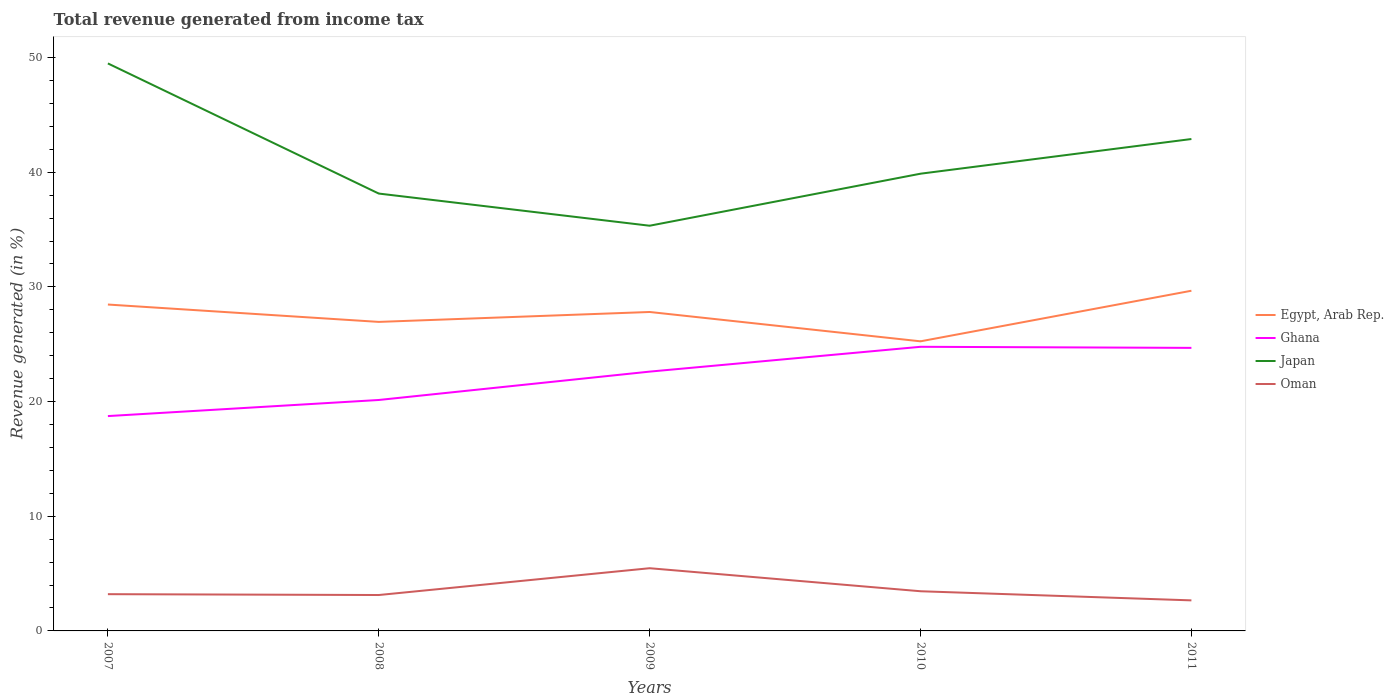How many different coloured lines are there?
Keep it short and to the point. 4. Across all years, what is the maximum total revenue generated in Ghana?
Offer a very short reply. 18.74. What is the total total revenue generated in Japan in the graph?
Your response must be concise. 11.35. What is the difference between the highest and the second highest total revenue generated in Oman?
Give a very brief answer. 2.8. Is the total revenue generated in Egypt, Arab Rep. strictly greater than the total revenue generated in Ghana over the years?
Make the answer very short. No. How many years are there in the graph?
Give a very brief answer. 5. What is the difference between two consecutive major ticks on the Y-axis?
Offer a terse response. 10. Are the values on the major ticks of Y-axis written in scientific E-notation?
Give a very brief answer. No. Does the graph contain any zero values?
Keep it short and to the point. No. Does the graph contain grids?
Offer a terse response. No. Where does the legend appear in the graph?
Keep it short and to the point. Center right. How are the legend labels stacked?
Make the answer very short. Vertical. What is the title of the graph?
Make the answer very short. Total revenue generated from income tax. Does "High income: nonOECD" appear as one of the legend labels in the graph?
Offer a terse response. No. What is the label or title of the X-axis?
Your response must be concise. Years. What is the label or title of the Y-axis?
Offer a very short reply. Revenue generated (in %). What is the Revenue generated (in %) of Egypt, Arab Rep. in 2007?
Your response must be concise. 28.46. What is the Revenue generated (in %) in Ghana in 2007?
Keep it short and to the point. 18.74. What is the Revenue generated (in %) in Japan in 2007?
Your answer should be very brief. 49.49. What is the Revenue generated (in %) of Oman in 2007?
Your answer should be compact. 3.2. What is the Revenue generated (in %) in Egypt, Arab Rep. in 2008?
Your answer should be compact. 26.95. What is the Revenue generated (in %) of Ghana in 2008?
Provide a short and direct response. 20.14. What is the Revenue generated (in %) of Japan in 2008?
Offer a terse response. 38.14. What is the Revenue generated (in %) in Oman in 2008?
Provide a succinct answer. 3.13. What is the Revenue generated (in %) in Egypt, Arab Rep. in 2009?
Keep it short and to the point. 27.81. What is the Revenue generated (in %) of Ghana in 2009?
Ensure brevity in your answer.  22.61. What is the Revenue generated (in %) of Japan in 2009?
Offer a terse response. 35.34. What is the Revenue generated (in %) of Oman in 2009?
Ensure brevity in your answer.  5.47. What is the Revenue generated (in %) in Egypt, Arab Rep. in 2010?
Your response must be concise. 25.26. What is the Revenue generated (in %) of Ghana in 2010?
Provide a succinct answer. 24.78. What is the Revenue generated (in %) in Japan in 2010?
Make the answer very short. 39.87. What is the Revenue generated (in %) in Oman in 2010?
Keep it short and to the point. 3.46. What is the Revenue generated (in %) of Egypt, Arab Rep. in 2011?
Give a very brief answer. 29.67. What is the Revenue generated (in %) in Ghana in 2011?
Offer a very short reply. 24.68. What is the Revenue generated (in %) of Japan in 2011?
Keep it short and to the point. 42.9. What is the Revenue generated (in %) in Oman in 2011?
Your answer should be very brief. 2.66. Across all years, what is the maximum Revenue generated (in %) in Egypt, Arab Rep.?
Your answer should be compact. 29.67. Across all years, what is the maximum Revenue generated (in %) in Ghana?
Your answer should be compact. 24.78. Across all years, what is the maximum Revenue generated (in %) in Japan?
Offer a terse response. 49.49. Across all years, what is the maximum Revenue generated (in %) of Oman?
Keep it short and to the point. 5.47. Across all years, what is the minimum Revenue generated (in %) in Egypt, Arab Rep.?
Provide a succinct answer. 25.26. Across all years, what is the minimum Revenue generated (in %) in Ghana?
Offer a very short reply. 18.74. Across all years, what is the minimum Revenue generated (in %) of Japan?
Make the answer very short. 35.34. Across all years, what is the minimum Revenue generated (in %) of Oman?
Offer a terse response. 2.66. What is the total Revenue generated (in %) of Egypt, Arab Rep. in the graph?
Your response must be concise. 138.15. What is the total Revenue generated (in %) of Ghana in the graph?
Offer a terse response. 110.95. What is the total Revenue generated (in %) of Japan in the graph?
Your answer should be compact. 205.73. What is the total Revenue generated (in %) in Oman in the graph?
Keep it short and to the point. 17.93. What is the difference between the Revenue generated (in %) in Egypt, Arab Rep. in 2007 and that in 2008?
Give a very brief answer. 1.51. What is the difference between the Revenue generated (in %) in Ghana in 2007 and that in 2008?
Your response must be concise. -1.4. What is the difference between the Revenue generated (in %) in Japan in 2007 and that in 2008?
Keep it short and to the point. 11.35. What is the difference between the Revenue generated (in %) of Oman in 2007 and that in 2008?
Provide a short and direct response. 0.07. What is the difference between the Revenue generated (in %) in Egypt, Arab Rep. in 2007 and that in 2009?
Your response must be concise. 0.65. What is the difference between the Revenue generated (in %) in Ghana in 2007 and that in 2009?
Ensure brevity in your answer.  -3.88. What is the difference between the Revenue generated (in %) of Japan in 2007 and that in 2009?
Offer a terse response. 14.15. What is the difference between the Revenue generated (in %) in Oman in 2007 and that in 2009?
Offer a very short reply. -2.26. What is the difference between the Revenue generated (in %) in Egypt, Arab Rep. in 2007 and that in 2010?
Provide a succinct answer. 3.21. What is the difference between the Revenue generated (in %) in Ghana in 2007 and that in 2010?
Your answer should be compact. -6.04. What is the difference between the Revenue generated (in %) in Japan in 2007 and that in 2010?
Keep it short and to the point. 9.62. What is the difference between the Revenue generated (in %) of Oman in 2007 and that in 2010?
Make the answer very short. -0.26. What is the difference between the Revenue generated (in %) in Egypt, Arab Rep. in 2007 and that in 2011?
Ensure brevity in your answer.  -1.2. What is the difference between the Revenue generated (in %) in Ghana in 2007 and that in 2011?
Your answer should be very brief. -5.95. What is the difference between the Revenue generated (in %) of Japan in 2007 and that in 2011?
Provide a short and direct response. 6.59. What is the difference between the Revenue generated (in %) of Oman in 2007 and that in 2011?
Give a very brief answer. 0.54. What is the difference between the Revenue generated (in %) of Egypt, Arab Rep. in 2008 and that in 2009?
Your response must be concise. -0.86. What is the difference between the Revenue generated (in %) of Ghana in 2008 and that in 2009?
Your answer should be very brief. -2.47. What is the difference between the Revenue generated (in %) of Japan in 2008 and that in 2009?
Ensure brevity in your answer.  2.8. What is the difference between the Revenue generated (in %) in Oman in 2008 and that in 2009?
Your answer should be compact. -2.34. What is the difference between the Revenue generated (in %) in Egypt, Arab Rep. in 2008 and that in 2010?
Keep it short and to the point. 1.69. What is the difference between the Revenue generated (in %) in Ghana in 2008 and that in 2010?
Your response must be concise. -4.64. What is the difference between the Revenue generated (in %) of Japan in 2008 and that in 2010?
Your answer should be very brief. -1.73. What is the difference between the Revenue generated (in %) in Oman in 2008 and that in 2010?
Ensure brevity in your answer.  -0.33. What is the difference between the Revenue generated (in %) of Egypt, Arab Rep. in 2008 and that in 2011?
Ensure brevity in your answer.  -2.72. What is the difference between the Revenue generated (in %) in Ghana in 2008 and that in 2011?
Offer a terse response. -4.54. What is the difference between the Revenue generated (in %) of Japan in 2008 and that in 2011?
Give a very brief answer. -4.76. What is the difference between the Revenue generated (in %) of Oman in 2008 and that in 2011?
Offer a very short reply. 0.47. What is the difference between the Revenue generated (in %) of Egypt, Arab Rep. in 2009 and that in 2010?
Keep it short and to the point. 2.56. What is the difference between the Revenue generated (in %) in Ghana in 2009 and that in 2010?
Your answer should be very brief. -2.16. What is the difference between the Revenue generated (in %) in Japan in 2009 and that in 2010?
Provide a short and direct response. -4.54. What is the difference between the Revenue generated (in %) in Oman in 2009 and that in 2010?
Give a very brief answer. 2.01. What is the difference between the Revenue generated (in %) of Egypt, Arab Rep. in 2009 and that in 2011?
Keep it short and to the point. -1.85. What is the difference between the Revenue generated (in %) of Ghana in 2009 and that in 2011?
Offer a very short reply. -2.07. What is the difference between the Revenue generated (in %) of Japan in 2009 and that in 2011?
Provide a succinct answer. -7.56. What is the difference between the Revenue generated (in %) of Oman in 2009 and that in 2011?
Your answer should be very brief. 2.8. What is the difference between the Revenue generated (in %) in Egypt, Arab Rep. in 2010 and that in 2011?
Provide a short and direct response. -4.41. What is the difference between the Revenue generated (in %) in Ghana in 2010 and that in 2011?
Give a very brief answer. 0.09. What is the difference between the Revenue generated (in %) of Japan in 2010 and that in 2011?
Provide a succinct answer. -3.02. What is the difference between the Revenue generated (in %) in Oman in 2010 and that in 2011?
Keep it short and to the point. 0.8. What is the difference between the Revenue generated (in %) in Egypt, Arab Rep. in 2007 and the Revenue generated (in %) in Ghana in 2008?
Keep it short and to the point. 8.32. What is the difference between the Revenue generated (in %) of Egypt, Arab Rep. in 2007 and the Revenue generated (in %) of Japan in 2008?
Offer a very short reply. -9.68. What is the difference between the Revenue generated (in %) in Egypt, Arab Rep. in 2007 and the Revenue generated (in %) in Oman in 2008?
Offer a very short reply. 25.33. What is the difference between the Revenue generated (in %) in Ghana in 2007 and the Revenue generated (in %) in Japan in 2008?
Offer a very short reply. -19.41. What is the difference between the Revenue generated (in %) of Ghana in 2007 and the Revenue generated (in %) of Oman in 2008?
Your answer should be very brief. 15.6. What is the difference between the Revenue generated (in %) of Japan in 2007 and the Revenue generated (in %) of Oman in 2008?
Your answer should be very brief. 46.36. What is the difference between the Revenue generated (in %) in Egypt, Arab Rep. in 2007 and the Revenue generated (in %) in Ghana in 2009?
Give a very brief answer. 5.85. What is the difference between the Revenue generated (in %) in Egypt, Arab Rep. in 2007 and the Revenue generated (in %) in Japan in 2009?
Offer a terse response. -6.87. What is the difference between the Revenue generated (in %) in Egypt, Arab Rep. in 2007 and the Revenue generated (in %) in Oman in 2009?
Offer a very short reply. 22.99. What is the difference between the Revenue generated (in %) in Ghana in 2007 and the Revenue generated (in %) in Japan in 2009?
Keep it short and to the point. -16.6. What is the difference between the Revenue generated (in %) in Ghana in 2007 and the Revenue generated (in %) in Oman in 2009?
Ensure brevity in your answer.  13.27. What is the difference between the Revenue generated (in %) of Japan in 2007 and the Revenue generated (in %) of Oman in 2009?
Give a very brief answer. 44.02. What is the difference between the Revenue generated (in %) of Egypt, Arab Rep. in 2007 and the Revenue generated (in %) of Ghana in 2010?
Provide a short and direct response. 3.69. What is the difference between the Revenue generated (in %) in Egypt, Arab Rep. in 2007 and the Revenue generated (in %) in Japan in 2010?
Provide a short and direct response. -11.41. What is the difference between the Revenue generated (in %) in Egypt, Arab Rep. in 2007 and the Revenue generated (in %) in Oman in 2010?
Offer a very short reply. 25. What is the difference between the Revenue generated (in %) in Ghana in 2007 and the Revenue generated (in %) in Japan in 2010?
Provide a succinct answer. -21.14. What is the difference between the Revenue generated (in %) of Ghana in 2007 and the Revenue generated (in %) of Oman in 2010?
Your answer should be compact. 15.28. What is the difference between the Revenue generated (in %) in Japan in 2007 and the Revenue generated (in %) in Oman in 2010?
Your answer should be very brief. 46.03. What is the difference between the Revenue generated (in %) in Egypt, Arab Rep. in 2007 and the Revenue generated (in %) in Ghana in 2011?
Offer a terse response. 3.78. What is the difference between the Revenue generated (in %) of Egypt, Arab Rep. in 2007 and the Revenue generated (in %) of Japan in 2011?
Your answer should be compact. -14.43. What is the difference between the Revenue generated (in %) in Egypt, Arab Rep. in 2007 and the Revenue generated (in %) in Oman in 2011?
Make the answer very short. 25.8. What is the difference between the Revenue generated (in %) of Ghana in 2007 and the Revenue generated (in %) of Japan in 2011?
Your answer should be very brief. -24.16. What is the difference between the Revenue generated (in %) of Ghana in 2007 and the Revenue generated (in %) of Oman in 2011?
Provide a short and direct response. 16.07. What is the difference between the Revenue generated (in %) of Japan in 2007 and the Revenue generated (in %) of Oman in 2011?
Your response must be concise. 46.83. What is the difference between the Revenue generated (in %) in Egypt, Arab Rep. in 2008 and the Revenue generated (in %) in Ghana in 2009?
Make the answer very short. 4.34. What is the difference between the Revenue generated (in %) in Egypt, Arab Rep. in 2008 and the Revenue generated (in %) in Japan in 2009?
Your answer should be very brief. -8.39. What is the difference between the Revenue generated (in %) in Egypt, Arab Rep. in 2008 and the Revenue generated (in %) in Oman in 2009?
Keep it short and to the point. 21.48. What is the difference between the Revenue generated (in %) in Ghana in 2008 and the Revenue generated (in %) in Japan in 2009?
Offer a terse response. -15.2. What is the difference between the Revenue generated (in %) of Ghana in 2008 and the Revenue generated (in %) of Oman in 2009?
Your response must be concise. 14.67. What is the difference between the Revenue generated (in %) of Japan in 2008 and the Revenue generated (in %) of Oman in 2009?
Keep it short and to the point. 32.67. What is the difference between the Revenue generated (in %) of Egypt, Arab Rep. in 2008 and the Revenue generated (in %) of Ghana in 2010?
Provide a succinct answer. 2.17. What is the difference between the Revenue generated (in %) in Egypt, Arab Rep. in 2008 and the Revenue generated (in %) in Japan in 2010?
Provide a succinct answer. -12.92. What is the difference between the Revenue generated (in %) in Egypt, Arab Rep. in 2008 and the Revenue generated (in %) in Oman in 2010?
Offer a very short reply. 23.49. What is the difference between the Revenue generated (in %) in Ghana in 2008 and the Revenue generated (in %) in Japan in 2010?
Offer a very short reply. -19.73. What is the difference between the Revenue generated (in %) of Ghana in 2008 and the Revenue generated (in %) of Oman in 2010?
Offer a very short reply. 16.68. What is the difference between the Revenue generated (in %) of Japan in 2008 and the Revenue generated (in %) of Oman in 2010?
Provide a succinct answer. 34.68. What is the difference between the Revenue generated (in %) of Egypt, Arab Rep. in 2008 and the Revenue generated (in %) of Ghana in 2011?
Your response must be concise. 2.27. What is the difference between the Revenue generated (in %) in Egypt, Arab Rep. in 2008 and the Revenue generated (in %) in Japan in 2011?
Offer a terse response. -15.95. What is the difference between the Revenue generated (in %) of Egypt, Arab Rep. in 2008 and the Revenue generated (in %) of Oman in 2011?
Your answer should be compact. 24.28. What is the difference between the Revenue generated (in %) in Ghana in 2008 and the Revenue generated (in %) in Japan in 2011?
Ensure brevity in your answer.  -22.76. What is the difference between the Revenue generated (in %) of Ghana in 2008 and the Revenue generated (in %) of Oman in 2011?
Keep it short and to the point. 17.48. What is the difference between the Revenue generated (in %) of Japan in 2008 and the Revenue generated (in %) of Oman in 2011?
Give a very brief answer. 35.48. What is the difference between the Revenue generated (in %) in Egypt, Arab Rep. in 2009 and the Revenue generated (in %) in Ghana in 2010?
Keep it short and to the point. 3.04. What is the difference between the Revenue generated (in %) of Egypt, Arab Rep. in 2009 and the Revenue generated (in %) of Japan in 2010?
Provide a short and direct response. -12.06. What is the difference between the Revenue generated (in %) in Egypt, Arab Rep. in 2009 and the Revenue generated (in %) in Oman in 2010?
Provide a short and direct response. 24.35. What is the difference between the Revenue generated (in %) in Ghana in 2009 and the Revenue generated (in %) in Japan in 2010?
Provide a succinct answer. -17.26. What is the difference between the Revenue generated (in %) in Ghana in 2009 and the Revenue generated (in %) in Oman in 2010?
Ensure brevity in your answer.  19.15. What is the difference between the Revenue generated (in %) of Japan in 2009 and the Revenue generated (in %) of Oman in 2010?
Give a very brief answer. 31.88. What is the difference between the Revenue generated (in %) of Egypt, Arab Rep. in 2009 and the Revenue generated (in %) of Ghana in 2011?
Keep it short and to the point. 3.13. What is the difference between the Revenue generated (in %) in Egypt, Arab Rep. in 2009 and the Revenue generated (in %) in Japan in 2011?
Provide a succinct answer. -15.08. What is the difference between the Revenue generated (in %) of Egypt, Arab Rep. in 2009 and the Revenue generated (in %) of Oman in 2011?
Provide a succinct answer. 25.15. What is the difference between the Revenue generated (in %) of Ghana in 2009 and the Revenue generated (in %) of Japan in 2011?
Your answer should be compact. -20.28. What is the difference between the Revenue generated (in %) in Ghana in 2009 and the Revenue generated (in %) in Oman in 2011?
Offer a terse response. 19.95. What is the difference between the Revenue generated (in %) in Japan in 2009 and the Revenue generated (in %) in Oman in 2011?
Make the answer very short. 32.67. What is the difference between the Revenue generated (in %) of Egypt, Arab Rep. in 2010 and the Revenue generated (in %) of Ghana in 2011?
Your answer should be very brief. 0.57. What is the difference between the Revenue generated (in %) of Egypt, Arab Rep. in 2010 and the Revenue generated (in %) of Japan in 2011?
Keep it short and to the point. -17.64. What is the difference between the Revenue generated (in %) in Egypt, Arab Rep. in 2010 and the Revenue generated (in %) in Oman in 2011?
Your answer should be very brief. 22.59. What is the difference between the Revenue generated (in %) of Ghana in 2010 and the Revenue generated (in %) of Japan in 2011?
Provide a succinct answer. -18.12. What is the difference between the Revenue generated (in %) in Ghana in 2010 and the Revenue generated (in %) in Oman in 2011?
Offer a very short reply. 22.11. What is the difference between the Revenue generated (in %) in Japan in 2010 and the Revenue generated (in %) in Oman in 2011?
Your answer should be compact. 37.21. What is the average Revenue generated (in %) of Egypt, Arab Rep. per year?
Keep it short and to the point. 27.63. What is the average Revenue generated (in %) in Ghana per year?
Offer a very short reply. 22.19. What is the average Revenue generated (in %) in Japan per year?
Your answer should be compact. 41.15. What is the average Revenue generated (in %) of Oman per year?
Make the answer very short. 3.59. In the year 2007, what is the difference between the Revenue generated (in %) of Egypt, Arab Rep. and Revenue generated (in %) of Ghana?
Your answer should be compact. 9.73. In the year 2007, what is the difference between the Revenue generated (in %) in Egypt, Arab Rep. and Revenue generated (in %) in Japan?
Offer a very short reply. -21.03. In the year 2007, what is the difference between the Revenue generated (in %) in Egypt, Arab Rep. and Revenue generated (in %) in Oman?
Provide a short and direct response. 25.26. In the year 2007, what is the difference between the Revenue generated (in %) in Ghana and Revenue generated (in %) in Japan?
Your answer should be compact. -30.75. In the year 2007, what is the difference between the Revenue generated (in %) of Ghana and Revenue generated (in %) of Oman?
Ensure brevity in your answer.  15.53. In the year 2007, what is the difference between the Revenue generated (in %) in Japan and Revenue generated (in %) in Oman?
Offer a terse response. 46.28. In the year 2008, what is the difference between the Revenue generated (in %) in Egypt, Arab Rep. and Revenue generated (in %) in Ghana?
Your response must be concise. 6.81. In the year 2008, what is the difference between the Revenue generated (in %) in Egypt, Arab Rep. and Revenue generated (in %) in Japan?
Keep it short and to the point. -11.19. In the year 2008, what is the difference between the Revenue generated (in %) of Egypt, Arab Rep. and Revenue generated (in %) of Oman?
Your answer should be very brief. 23.82. In the year 2008, what is the difference between the Revenue generated (in %) in Ghana and Revenue generated (in %) in Japan?
Provide a succinct answer. -18. In the year 2008, what is the difference between the Revenue generated (in %) of Ghana and Revenue generated (in %) of Oman?
Keep it short and to the point. 17.01. In the year 2008, what is the difference between the Revenue generated (in %) of Japan and Revenue generated (in %) of Oman?
Offer a very short reply. 35.01. In the year 2009, what is the difference between the Revenue generated (in %) of Egypt, Arab Rep. and Revenue generated (in %) of Ghana?
Offer a terse response. 5.2. In the year 2009, what is the difference between the Revenue generated (in %) of Egypt, Arab Rep. and Revenue generated (in %) of Japan?
Provide a short and direct response. -7.52. In the year 2009, what is the difference between the Revenue generated (in %) in Egypt, Arab Rep. and Revenue generated (in %) in Oman?
Offer a very short reply. 22.35. In the year 2009, what is the difference between the Revenue generated (in %) in Ghana and Revenue generated (in %) in Japan?
Your response must be concise. -12.72. In the year 2009, what is the difference between the Revenue generated (in %) in Ghana and Revenue generated (in %) in Oman?
Provide a succinct answer. 17.15. In the year 2009, what is the difference between the Revenue generated (in %) of Japan and Revenue generated (in %) of Oman?
Offer a terse response. 29.87. In the year 2010, what is the difference between the Revenue generated (in %) of Egypt, Arab Rep. and Revenue generated (in %) of Ghana?
Offer a very short reply. 0.48. In the year 2010, what is the difference between the Revenue generated (in %) in Egypt, Arab Rep. and Revenue generated (in %) in Japan?
Provide a short and direct response. -14.62. In the year 2010, what is the difference between the Revenue generated (in %) in Egypt, Arab Rep. and Revenue generated (in %) in Oman?
Make the answer very short. 21.8. In the year 2010, what is the difference between the Revenue generated (in %) in Ghana and Revenue generated (in %) in Japan?
Provide a short and direct response. -15.1. In the year 2010, what is the difference between the Revenue generated (in %) of Ghana and Revenue generated (in %) of Oman?
Keep it short and to the point. 21.32. In the year 2010, what is the difference between the Revenue generated (in %) of Japan and Revenue generated (in %) of Oman?
Keep it short and to the point. 36.41. In the year 2011, what is the difference between the Revenue generated (in %) in Egypt, Arab Rep. and Revenue generated (in %) in Ghana?
Offer a very short reply. 4.98. In the year 2011, what is the difference between the Revenue generated (in %) in Egypt, Arab Rep. and Revenue generated (in %) in Japan?
Ensure brevity in your answer.  -13.23. In the year 2011, what is the difference between the Revenue generated (in %) of Egypt, Arab Rep. and Revenue generated (in %) of Oman?
Keep it short and to the point. 27. In the year 2011, what is the difference between the Revenue generated (in %) of Ghana and Revenue generated (in %) of Japan?
Offer a terse response. -18.21. In the year 2011, what is the difference between the Revenue generated (in %) in Ghana and Revenue generated (in %) in Oman?
Make the answer very short. 22.02. In the year 2011, what is the difference between the Revenue generated (in %) of Japan and Revenue generated (in %) of Oman?
Offer a terse response. 40.23. What is the ratio of the Revenue generated (in %) in Egypt, Arab Rep. in 2007 to that in 2008?
Your answer should be very brief. 1.06. What is the ratio of the Revenue generated (in %) of Ghana in 2007 to that in 2008?
Provide a succinct answer. 0.93. What is the ratio of the Revenue generated (in %) of Japan in 2007 to that in 2008?
Offer a terse response. 1.3. What is the ratio of the Revenue generated (in %) of Oman in 2007 to that in 2008?
Provide a short and direct response. 1.02. What is the ratio of the Revenue generated (in %) of Egypt, Arab Rep. in 2007 to that in 2009?
Give a very brief answer. 1.02. What is the ratio of the Revenue generated (in %) of Ghana in 2007 to that in 2009?
Make the answer very short. 0.83. What is the ratio of the Revenue generated (in %) in Japan in 2007 to that in 2009?
Your answer should be compact. 1.4. What is the ratio of the Revenue generated (in %) in Oman in 2007 to that in 2009?
Your response must be concise. 0.59. What is the ratio of the Revenue generated (in %) in Egypt, Arab Rep. in 2007 to that in 2010?
Provide a short and direct response. 1.13. What is the ratio of the Revenue generated (in %) in Ghana in 2007 to that in 2010?
Provide a short and direct response. 0.76. What is the ratio of the Revenue generated (in %) of Japan in 2007 to that in 2010?
Give a very brief answer. 1.24. What is the ratio of the Revenue generated (in %) in Oman in 2007 to that in 2010?
Give a very brief answer. 0.93. What is the ratio of the Revenue generated (in %) in Egypt, Arab Rep. in 2007 to that in 2011?
Provide a succinct answer. 0.96. What is the ratio of the Revenue generated (in %) in Ghana in 2007 to that in 2011?
Your answer should be compact. 0.76. What is the ratio of the Revenue generated (in %) of Japan in 2007 to that in 2011?
Ensure brevity in your answer.  1.15. What is the ratio of the Revenue generated (in %) of Oman in 2007 to that in 2011?
Keep it short and to the point. 1.2. What is the ratio of the Revenue generated (in %) in Egypt, Arab Rep. in 2008 to that in 2009?
Your response must be concise. 0.97. What is the ratio of the Revenue generated (in %) in Ghana in 2008 to that in 2009?
Your answer should be very brief. 0.89. What is the ratio of the Revenue generated (in %) in Japan in 2008 to that in 2009?
Offer a very short reply. 1.08. What is the ratio of the Revenue generated (in %) in Oman in 2008 to that in 2009?
Keep it short and to the point. 0.57. What is the ratio of the Revenue generated (in %) in Egypt, Arab Rep. in 2008 to that in 2010?
Your answer should be compact. 1.07. What is the ratio of the Revenue generated (in %) of Ghana in 2008 to that in 2010?
Give a very brief answer. 0.81. What is the ratio of the Revenue generated (in %) in Japan in 2008 to that in 2010?
Offer a terse response. 0.96. What is the ratio of the Revenue generated (in %) in Oman in 2008 to that in 2010?
Keep it short and to the point. 0.9. What is the ratio of the Revenue generated (in %) in Egypt, Arab Rep. in 2008 to that in 2011?
Ensure brevity in your answer.  0.91. What is the ratio of the Revenue generated (in %) in Ghana in 2008 to that in 2011?
Offer a terse response. 0.82. What is the ratio of the Revenue generated (in %) of Japan in 2008 to that in 2011?
Keep it short and to the point. 0.89. What is the ratio of the Revenue generated (in %) in Oman in 2008 to that in 2011?
Provide a succinct answer. 1.18. What is the ratio of the Revenue generated (in %) in Egypt, Arab Rep. in 2009 to that in 2010?
Offer a terse response. 1.1. What is the ratio of the Revenue generated (in %) of Ghana in 2009 to that in 2010?
Your response must be concise. 0.91. What is the ratio of the Revenue generated (in %) of Japan in 2009 to that in 2010?
Make the answer very short. 0.89. What is the ratio of the Revenue generated (in %) in Oman in 2009 to that in 2010?
Your answer should be compact. 1.58. What is the ratio of the Revenue generated (in %) in Egypt, Arab Rep. in 2009 to that in 2011?
Make the answer very short. 0.94. What is the ratio of the Revenue generated (in %) in Ghana in 2009 to that in 2011?
Keep it short and to the point. 0.92. What is the ratio of the Revenue generated (in %) of Japan in 2009 to that in 2011?
Provide a succinct answer. 0.82. What is the ratio of the Revenue generated (in %) of Oman in 2009 to that in 2011?
Give a very brief answer. 2.05. What is the ratio of the Revenue generated (in %) of Egypt, Arab Rep. in 2010 to that in 2011?
Your answer should be compact. 0.85. What is the ratio of the Revenue generated (in %) in Ghana in 2010 to that in 2011?
Your answer should be compact. 1. What is the ratio of the Revenue generated (in %) of Japan in 2010 to that in 2011?
Your response must be concise. 0.93. What is the ratio of the Revenue generated (in %) in Oman in 2010 to that in 2011?
Provide a short and direct response. 1.3. What is the difference between the highest and the second highest Revenue generated (in %) in Egypt, Arab Rep.?
Offer a terse response. 1.2. What is the difference between the highest and the second highest Revenue generated (in %) of Ghana?
Make the answer very short. 0.09. What is the difference between the highest and the second highest Revenue generated (in %) in Japan?
Provide a succinct answer. 6.59. What is the difference between the highest and the second highest Revenue generated (in %) in Oman?
Ensure brevity in your answer.  2.01. What is the difference between the highest and the lowest Revenue generated (in %) of Egypt, Arab Rep.?
Ensure brevity in your answer.  4.41. What is the difference between the highest and the lowest Revenue generated (in %) of Ghana?
Keep it short and to the point. 6.04. What is the difference between the highest and the lowest Revenue generated (in %) of Japan?
Make the answer very short. 14.15. What is the difference between the highest and the lowest Revenue generated (in %) in Oman?
Offer a very short reply. 2.8. 